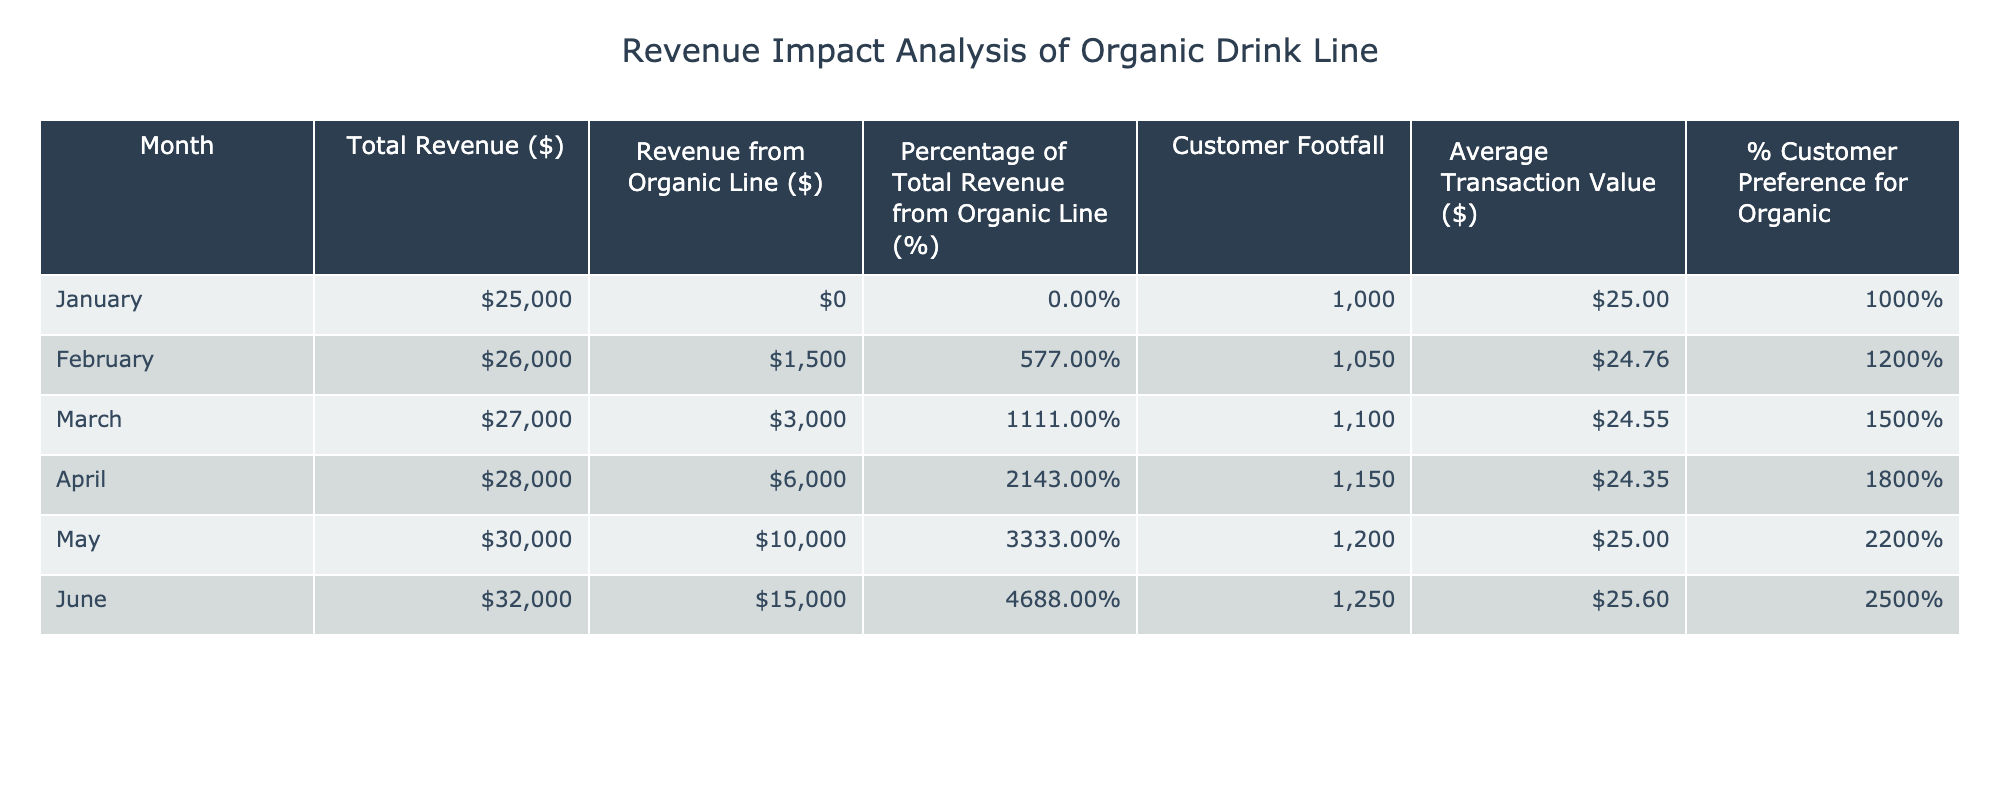What was the total revenue in June? From the table, the total revenue in June is directly listed under the "Total Revenue ($)" column for that month. In June, the figure is 32000.
Answer: 32000 What percentage of total revenue came from the organic line in May? The table shows that in May, the "Percentage of Total Revenue from Organic Line (%)" is 33.33. This figure is read directly from the table for May.
Answer: 33.33 What was the average customer footfall from January to March? To find the average customer footfall over January to March, I sum the customer footfalls for those months (1000 + 1050 + 1100 = 3150) and divide by the number of months (3): 3150 / 3 = 1050.
Answer: 1050 Did the percentage of customer preference for organic increase from January to June? By examining the table, January has a customer preference for organic at 10% and June has it at 25%. Since 25% is greater than 10%, the preference did indeed increase over this period.
Answer: Yes What is the total revenue from the organic line over the six months? To find the total revenue from the organic line, I sum the values for each month: 0 + 1500 + 3000 + 6000 + 10000 + 15000 = 32000.
Answer: 32000 How much did the average transaction value change from January to June? The average transaction value in January is 25 and in June it is 25.6. The change is calculated as 25.6 - 25 = 0.6, indicating an increase.
Answer: 0.6 What month had the highest percentage of total revenue coming from the organic line? By reviewing the table, June has the highest percentage of total revenue from the organic line at 46.88%. I can see it listed right for that month.
Answer: June Is it true that total revenue consistently increased each month? Upon analyzing the total revenue figures across the months, I find that January started at 25000 and climbed to 32000 in June, confirming the consistent increase throughout the six months.
Answer: Yes What was the increase in customer footfall from January to May? In January, the customer footfall was 1000, and in May it was 1200. The increase is calculated as 1200 - 1000 = 200. This gives me the total increase in footfall between these two months.
Answer: 200 